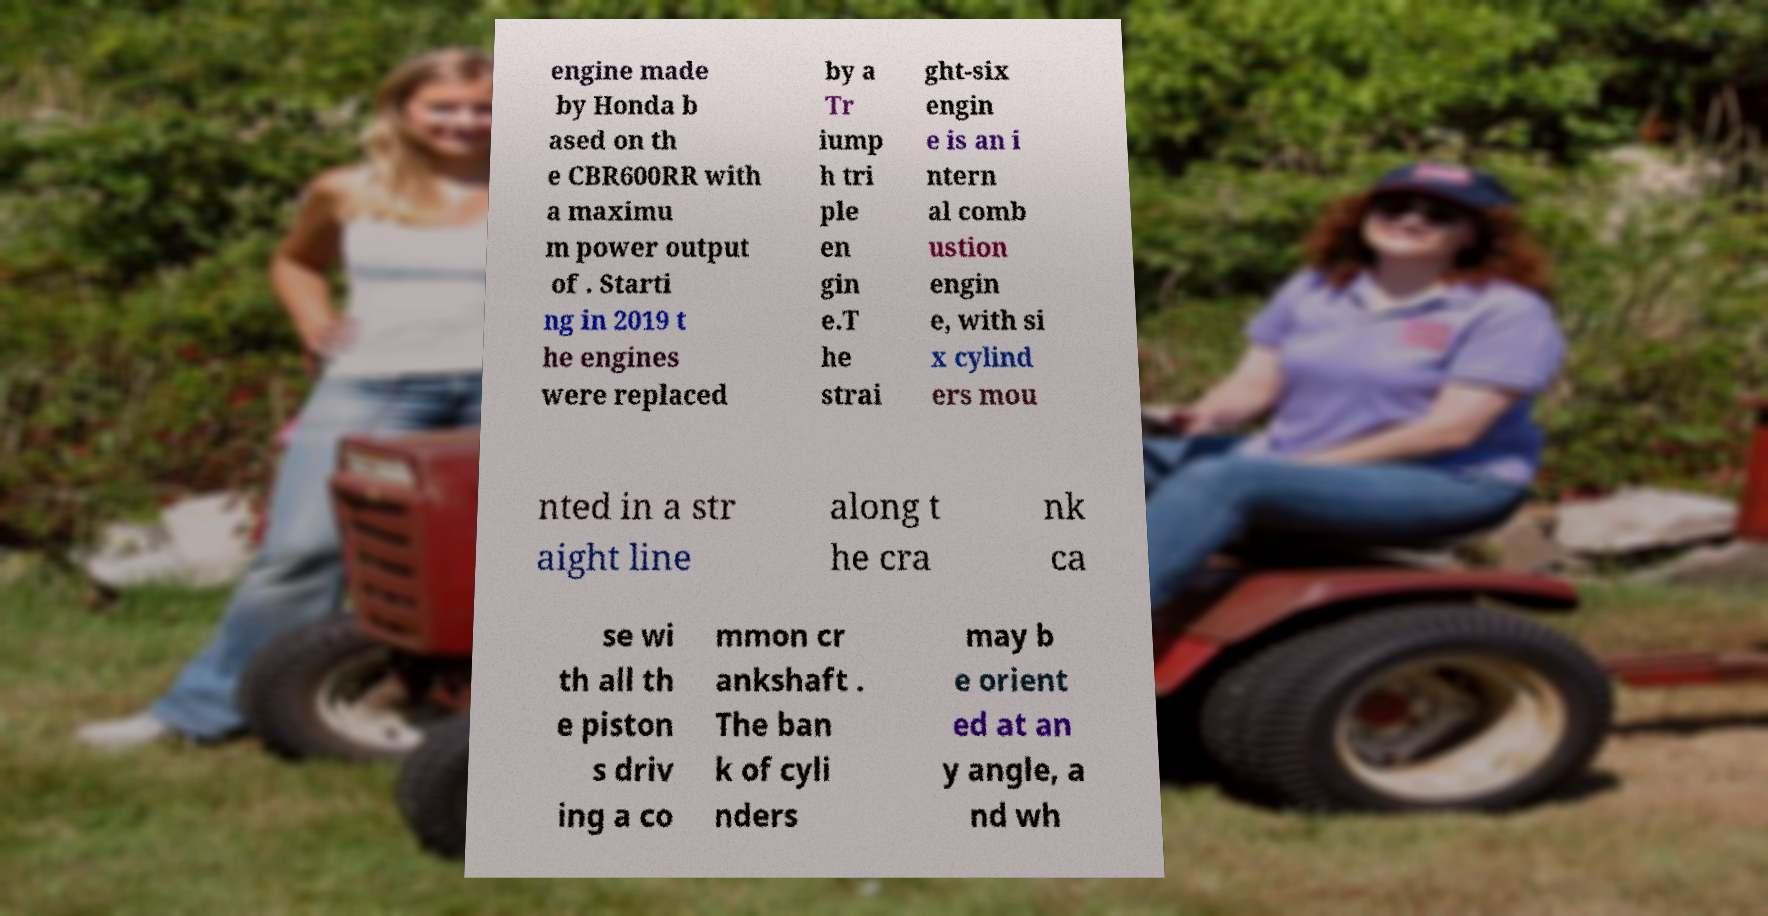Can you accurately transcribe the text from the provided image for me? engine made by Honda b ased on th e CBR600RR with a maximu m power output of . Starti ng in 2019 t he engines were replaced by a Tr iump h tri ple en gin e.T he strai ght-six engin e is an i ntern al comb ustion engin e, with si x cylind ers mou nted in a str aight line along t he cra nk ca se wi th all th e piston s driv ing a co mmon cr ankshaft . The ban k of cyli nders may b e orient ed at an y angle, a nd wh 